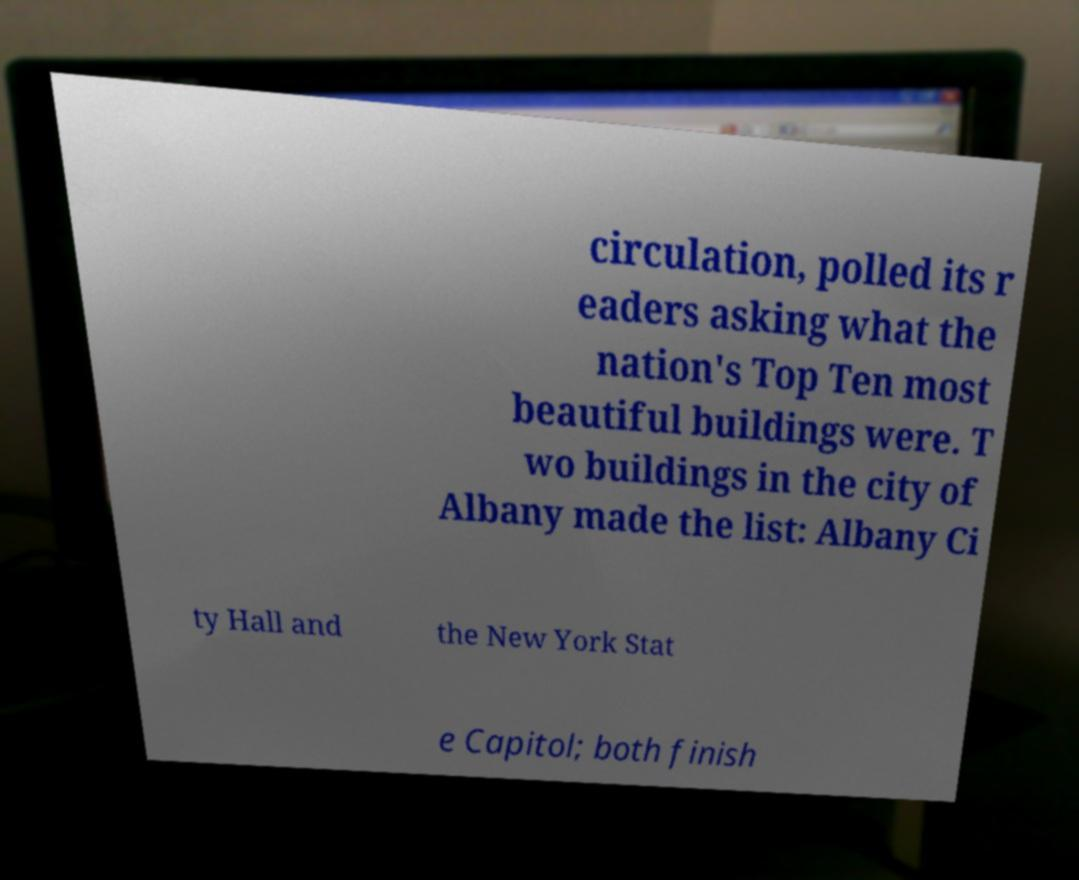Could you extract and type out the text from this image? circulation, polled its r eaders asking what the nation's Top Ten most beautiful buildings were. T wo buildings in the city of Albany made the list: Albany Ci ty Hall and the New York Stat e Capitol; both finish 